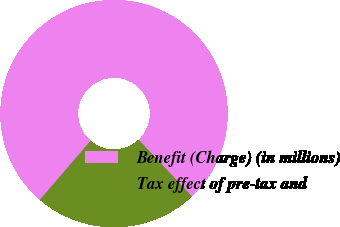<chart> <loc_0><loc_0><loc_500><loc_500><pie_chart><fcel>Benefit (Charge) (in millions)<fcel>Tax effect of pre-tax and<nl><fcel>76.68%<fcel>23.32%<nl></chart> 